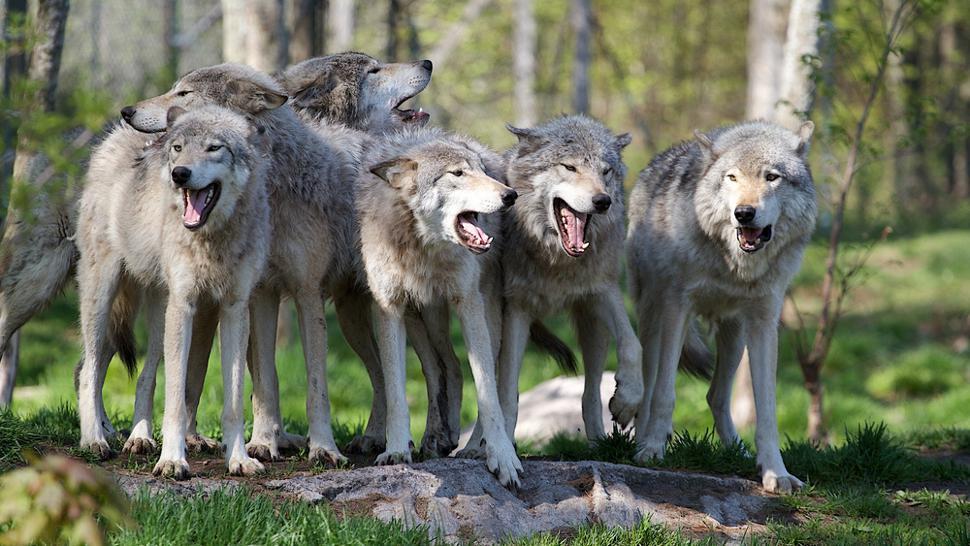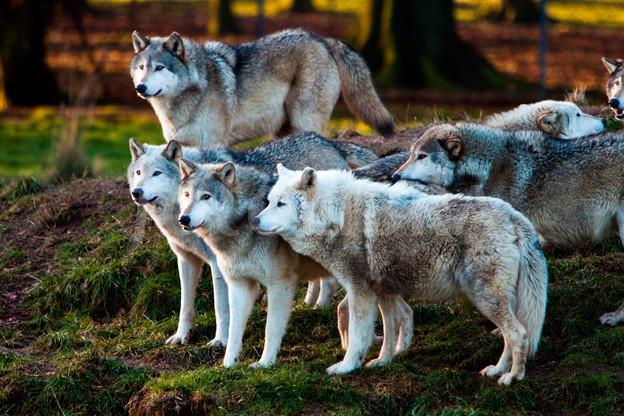The first image is the image on the left, the second image is the image on the right. Given the left and right images, does the statement "There is a black wolf on the left side of the image." hold true? Answer yes or no. No. The first image is the image on the left, the second image is the image on the right. Analyze the images presented: Is the assertion "There is at least one image where there are five or more wolves." valid? Answer yes or no. Yes. 